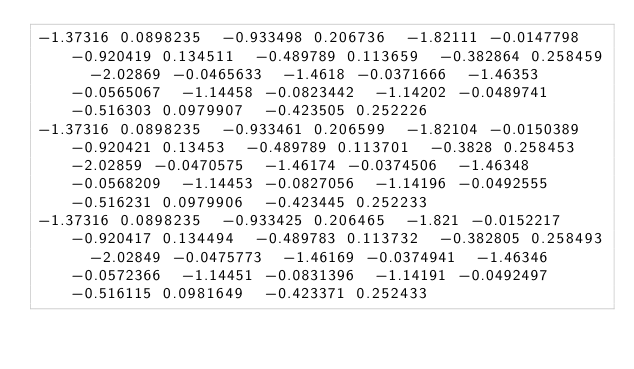<code> <loc_0><loc_0><loc_500><loc_500><_ObjectiveC_>-1.37316 0.0898235  -0.933498 0.206736  -1.82111 -0.0147798  -0.920419 0.134511  -0.489789 0.113659  -0.382864 0.258459  -2.02869 -0.0465633  -1.4618 -0.0371666  -1.46353 -0.0565067  -1.14458 -0.0823442  -1.14202 -0.0489741  -0.516303 0.0979907  -0.423505 0.252226  
-1.37316 0.0898235  -0.933461 0.206599  -1.82104 -0.0150389  -0.920421 0.13453  -0.489789 0.113701  -0.3828 0.258453  -2.02859 -0.0470575  -1.46174 -0.0374506  -1.46348 -0.0568209  -1.14453 -0.0827056  -1.14196 -0.0492555  -0.516231 0.0979906  -0.423445 0.252233  
-1.37316 0.0898235  -0.933425 0.206465  -1.821 -0.0152217  -0.920417 0.134494  -0.489783 0.113732  -0.382805 0.258493  -2.02849 -0.0475773  -1.46169 -0.0374941  -1.46346 -0.0572366  -1.14451 -0.0831396  -1.14191 -0.0492497  -0.516115 0.0981649  -0.423371 0.252433  </code> 